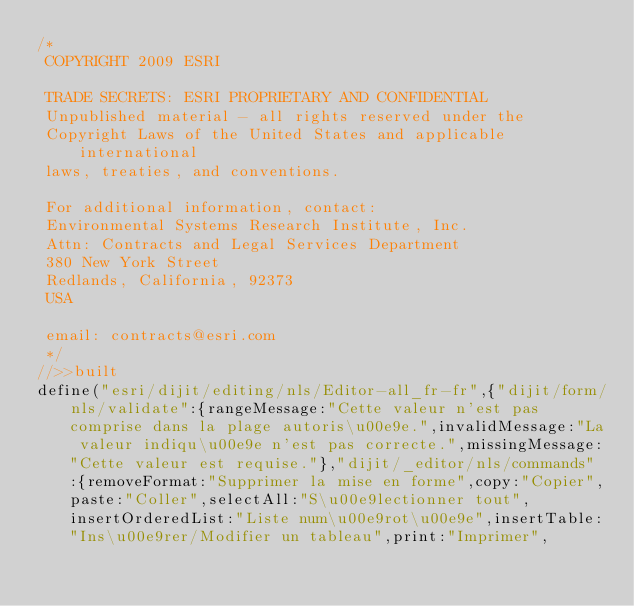<code> <loc_0><loc_0><loc_500><loc_500><_JavaScript_>/*
 COPYRIGHT 2009 ESRI

 TRADE SECRETS: ESRI PROPRIETARY AND CONFIDENTIAL
 Unpublished material - all rights reserved under the
 Copyright Laws of the United States and applicable international
 laws, treaties, and conventions.

 For additional information, contact:
 Environmental Systems Research Institute, Inc.
 Attn: Contracts and Legal Services Department
 380 New York Street
 Redlands, California, 92373
 USA

 email: contracts@esri.com
 */
//>>built
define("esri/dijit/editing/nls/Editor-all_fr-fr",{"dijit/form/nls/validate":{rangeMessage:"Cette valeur n'est pas comprise dans la plage autoris\u00e9e.",invalidMessage:"La valeur indiqu\u00e9e n'est pas correcte.",missingMessage:"Cette valeur est requise."},"dijit/_editor/nls/commands":{removeFormat:"Supprimer la mise en forme",copy:"Copier",paste:"Coller",selectAll:"S\u00e9lectionner tout",insertOrderedList:"Liste num\u00e9rot\u00e9e",insertTable:"Ins\u00e9rer/Modifier un tableau",print:"Imprimer",</code> 